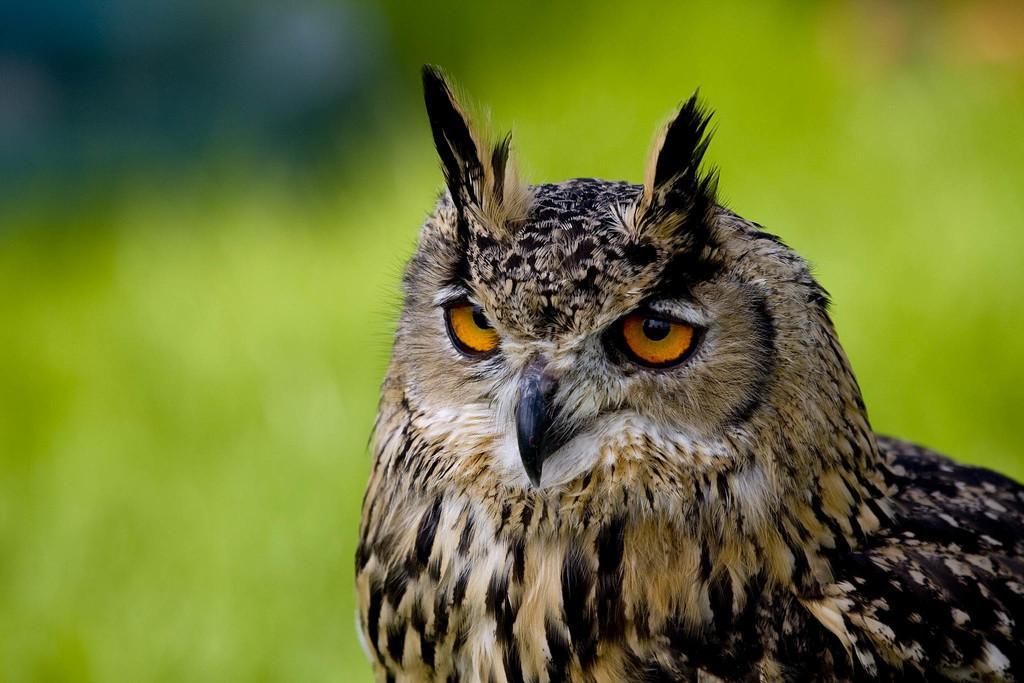In one or two sentences, can you explain what this image depicts? In this picture we can see an owl. Behind the owl, there is the blurred background. 